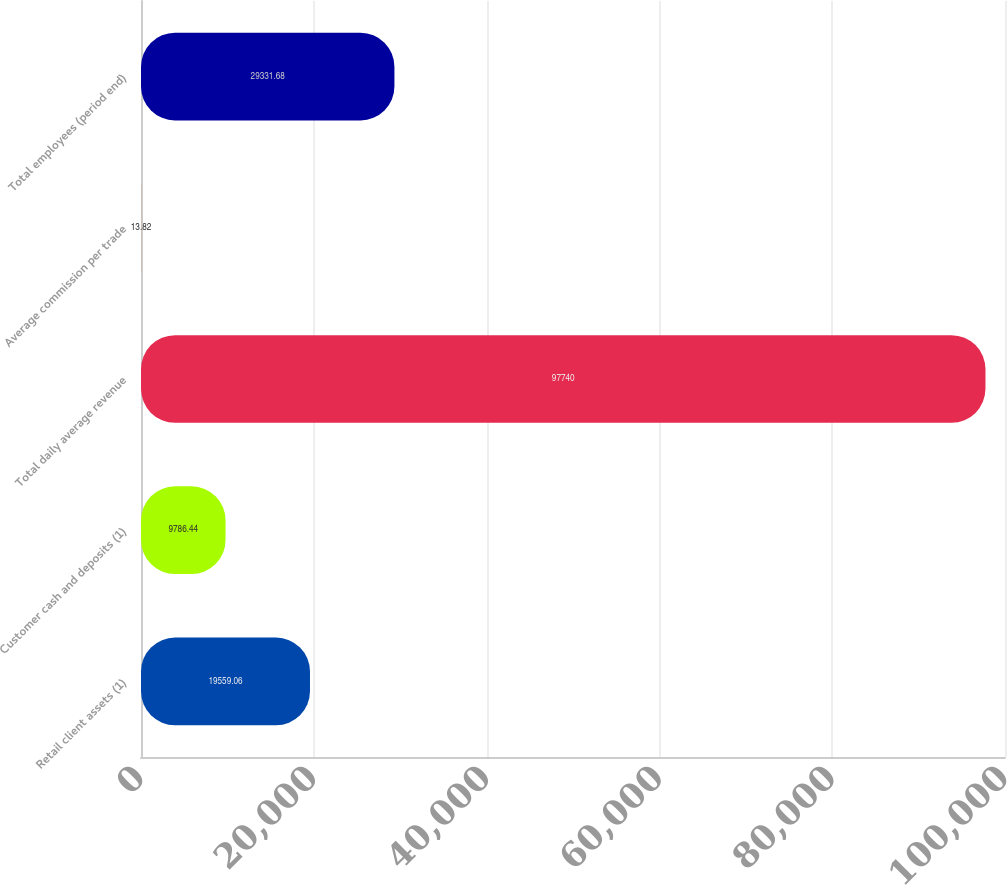<chart> <loc_0><loc_0><loc_500><loc_500><bar_chart><fcel>Retail client assets (1)<fcel>Customer cash and deposits (1)<fcel>Total daily average revenue<fcel>Average commission per trade<fcel>Total employees (period end)<nl><fcel>19559.1<fcel>9786.44<fcel>97740<fcel>13.82<fcel>29331.7<nl></chart> 